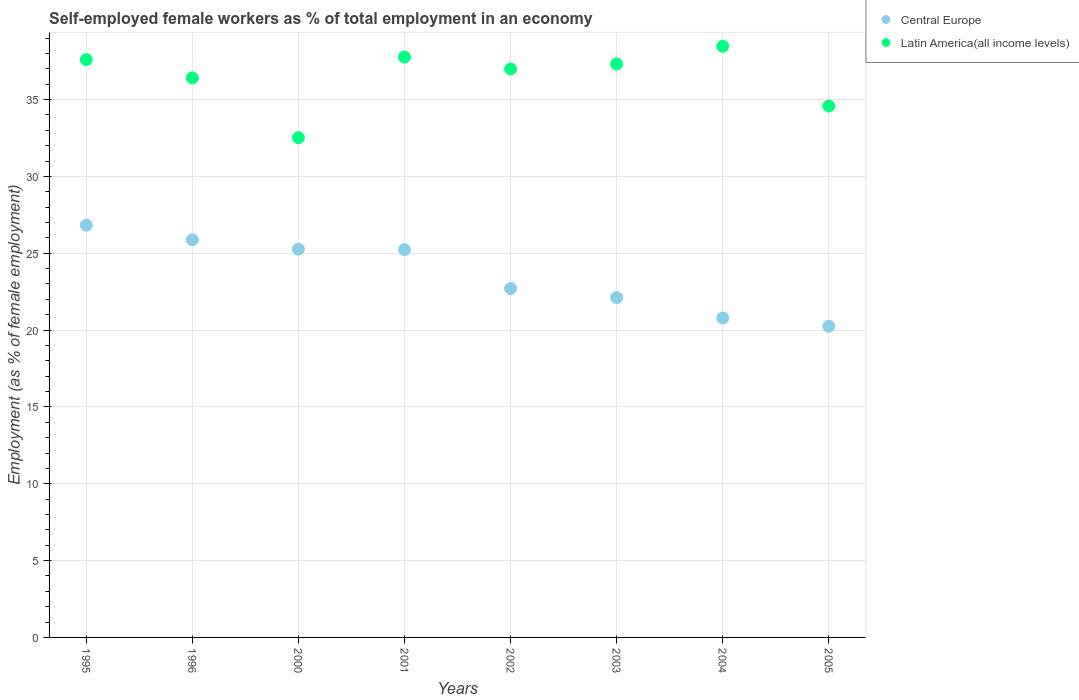Is the number of dotlines equal to the number of legend labels?
Your response must be concise. Yes. What is the percentage of self-employed female workers in Latin America(all income levels) in 2002?
Keep it short and to the point. 36.99. Across all years, what is the maximum percentage of self-employed female workers in Central Europe?
Your answer should be compact. 26.83. Across all years, what is the minimum percentage of self-employed female workers in Latin America(all income levels)?
Give a very brief answer. 32.52. What is the total percentage of self-employed female workers in Latin America(all income levels) in the graph?
Give a very brief answer. 291.67. What is the difference between the percentage of self-employed female workers in Central Europe in 2000 and that in 2004?
Your answer should be compact. 4.48. What is the difference between the percentage of self-employed female workers in Latin America(all income levels) in 1995 and the percentage of self-employed female workers in Central Europe in 2001?
Give a very brief answer. 12.37. What is the average percentage of self-employed female workers in Latin America(all income levels) per year?
Provide a short and direct response. 36.46. In the year 2005, what is the difference between the percentage of self-employed female workers in Latin America(all income levels) and percentage of self-employed female workers in Central Europe?
Your answer should be compact. 14.33. In how many years, is the percentage of self-employed female workers in Central Europe greater than 27 %?
Give a very brief answer. 0. What is the ratio of the percentage of self-employed female workers in Latin America(all income levels) in 1996 to that in 2001?
Make the answer very short. 0.96. Is the percentage of self-employed female workers in Central Europe in 2002 less than that in 2005?
Your answer should be very brief. No. Is the difference between the percentage of self-employed female workers in Latin America(all income levels) in 2001 and 2002 greater than the difference between the percentage of self-employed female workers in Central Europe in 2001 and 2002?
Provide a succinct answer. No. What is the difference between the highest and the second highest percentage of self-employed female workers in Central Europe?
Keep it short and to the point. 0.95. What is the difference between the highest and the lowest percentage of self-employed female workers in Latin America(all income levels)?
Offer a very short reply. 5.95. Does the percentage of self-employed female workers in Central Europe monotonically increase over the years?
Your response must be concise. No. Is the percentage of self-employed female workers in Latin America(all income levels) strictly greater than the percentage of self-employed female workers in Central Europe over the years?
Keep it short and to the point. Yes. How many dotlines are there?
Offer a very short reply. 2. What is the difference between two consecutive major ticks on the Y-axis?
Your response must be concise. 5. Are the values on the major ticks of Y-axis written in scientific E-notation?
Your answer should be very brief. No. Does the graph contain any zero values?
Provide a short and direct response. No. Where does the legend appear in the graph?
Provide a short and direct response. Top right. What is the title of the graph?
Keep it short and to the point. Self-employed female workers as % of total employment in an economy. Does "Guyana" appear as one of the legend labels in the graph?
Your response must be concise. No. What is the label or title of the X-axis?
Ensure brevity in your answer.  Years. What is the label or title of the Y-axis?
Ensure brevity in your answer.  Employment (as % of female employment). What is the Employment (as % of female employment) in Central Europe in 1995?
Give a very brief answer. 26.83. What is the Employment (as % of female employment) of Latin America(all income levels) in 1995?
Provide a short and direct response. 37.61. What is the Employment (as % of female employment) in Central Europe in 1996?
Give a very brief answer. 25.88. What is the Employment (as % of female employment) in Latin America(all income levels) in 1996?
Your answer should be compact. 36.41. What is the Employment (as % of female employment) in Central Europe in 2000?
Offer a terse response. 25.27. What is the Employment (as % of female employment) of Latin America(all income levels) in 2000?
Your answer should be compact. 32.52. What is the Employment (as % of female employment) in Central Europe in 2001?
Offer a terse response. 25.24. What is the Employment (as % of female employment) in Latin America(all income levels) in 2001?
Your response must be concise. 37.77. What is the Employment (as % of female employment) in Central Europe in 2002?
Provide a succinct answer. 22.71. What is the Employment (as % of female employment) of Latin America(all income levels) in 2002?
Give a very brief answer. 36.99. What is the Employment (as % of female employment) in Central Europe in 2003?
Keep it short and to the point. 22.12. What is the Employment (as % of female employment) of Latin America(all income levels) in 2003?
Offer a very short reply. 37.32. What is the Employment (as % of female employment) in Central Europe in 2004?
Your answer should be very brief. 20.78. What is the Employment (as % of female employment) of Latin America(all income levels) in 2004?
Keep it short and to the point. 38.47. What is the Employment (as % of female employment) in Central Europe in 2005?
Offer a very short reply. 20.25. What is the Employment (as % of female employment) in Latin America(all income levels) in 2005?
Your response must be concise. 34.58. Across all years, what is the maximum Employment (as % of female employment) of Central Europe?
Offer a terse response. 26.83. Across all years, what is the maximum Employment (as % of female employment) in Latin America(all income levels)?
Offer a very short reply. 38.47. Across all years, what is the minimum Employment (as % of female employment) of Central Europe?
Keep it short and to the point. 20.25. Across all years, what is the minimum Employment (as % of female employment) in Latin America(all income levels)?
Offer a terse response. 32.52. What is the total Employment (as % of female employment) in Central Europe in the graph?
Your response must be concise. 189.07. What is the total Employment (as % of female employment) in Latin America(all income levels) in the graph?
Provide a short and direct response. 291.67. What is the difference between the Employment (as % of female employment) of Central Europe in 1995 and that in 1996?
Ensure brevity in your answer.  0.95. What is the difference between the Employment (as % of female employment) of Latin America(all income levels) in 1995 and that in 1996?
Your answer should be compact. 1.2. What is the difference between the Employment (as % of female employment) in Central Europe in 1995 and that in 2000?
Offer a very short reply. 1.57. What is the difference between the Employment (as % of female employment) of Latin America(all income levels) in 1995 and that in 2000?
Give a very brief answer. 5.08. What is the difference between the Employment (as % of female employment) of Central Europe in 1995 and that in 2001?
Provide a short and direct response. 1.59. What is the difference between the Employment (as % of female employment) in Latin America(all income levels) in 1995 and that in 2001?
Provide a succinct answer. -0.17. What is the difference between the Employment (as % of female employment) in Central Europe in 1995 and that in 2002?
Offer a terse response. 4.12. What is the difference between the Employment (as % of female employment) in Latin America(all income levels) in 1995 and that in 2002?
Give a very brief answer. 0.61. What is the difference between the Employment (as % of female employment) in Central Europe in 1995 and that in 2003?
Give a very brief answer. 4.72. What is the difference between the Employment (as % of female employment) of Latin America(all income levels) in 1995 and that in 2003?
Your answer should be very brief. 0.29. What is the difference between the Employment (as % of female employment) in Central Europe in 1995 and that in 2004?
Your answer should be compact. 6.05. What is the difference between the Employment (as % of female employment) in Latin America(all income levels) in 1995 and that in 2004?
Your answer should be very brief. -0.86. What is the difference between the Employment (as % of female employment) of Central Europe in 1995 and that in 2005?
Ensure brevity in your answer.  6.59. What is the difference between the Employment (as % of female employment) of Latin America(all income levels) in 1995 and that in 2005?
Offer a very short reply. 3.03. What is the difference between the Employment (as % of female employment) in Central Europe in 1996 and that in 2000?
Your answer should be very brief. 0.61. What is the difference between the Employment (as % of female employment) of Latin America(all income levels) in 1996 and that in 2000?
Provide a short and direct response. 3.89. What is the difference between the Employment (as % of female employment) in Central Europe in 1996 and that in 2001?
Offer a very short reply. 0.64. What is the difference between the Employment (as % of female employment) in Latin America(all income levels) in 1996 and that in 2001?
Give a very brief answer. -1.36. What is the difference between the Employment (as % of female employment) in Central Europe in 1996 and that in 2002?
Give a very brief answer. 3.17. What is the difference between the Employment (as % of female employment) in Latin America(all income levels) in 1996 and that in 2002?
Provide a short and direct response. -0.58. What is the difference between the Employment (as % of female employment) of Central Europe in 1996 and that in 2003?
Ensure brevity in your answer.  3.76. What is the difference between the Employment (as % of female employment) of Latin America(all income levels) in 1996 and that in 2003?
Ensure brevity in your answer.  -0.91. What is the difference between the Employment (as % of female employment) in Central Europe in 1996 and that in 2004?
Your response must be concise. 5.1. What is the difference between the Employment (as % of female employment) in Latin America(all income levels) in 1996 and that in 2004?
Provide a succinct answer. -2.06. What is the difference between the Employment (as % of female employment) in Central Europe in 1996 and that in 2005?
Provide a succinct answer. 5.63. What is the difference between the Employment (as % of female employment) of Latin America(all income levels) in 1996 and that in 2005?
Ensure brevity in your answer.  1.83. What is the difference between the Employment (as % of female employment) in Central Europe in 2000 and that in 2001?
Keep it short and to the point. 0.03. What is the difference between the Employment (as % of female employment) of Latin America(all income levels) in 2000 and that in 2001?
Offer a very short reply. -5.25. What is the difference between the Employment (as % of female employment) in Central Europe in 2000 and that in 2002?
Provide a short and direct response. 2.56. What is the difference between the Employment (as % of female employment) of Latin America(all income levels) in 2000 and that in 2002?
Ensure brevity in your answer.  -4.47. What is the difference between the Employment (as % of female employment) in Central Europe in 2000 and that in 2003?
Your answer should be very brief. 3.15. What is the difference between the Employment (as % of female employment) in Latin America(all income levels) in 2000 and that in 2003?
Offer a terse response. -4.8. What is the difference between the Employment (as % of female employment) in Central Europe in 2000 and that in 2004?
Ensure brevity in your answer.  4.48. What is the difference between the Employment (as % of female employment) in Latin America(all income levels) in 2000 and that in 2004?
Give a very brief answer. -5.95. What is the difference between the Employment (as % of female employment) of Central Europe in 2000 and that in 2005?
Offer a very short reply. 5.02. What is the difference between the Employment (as % of female employment) in Latin America(all income levels) in 2000 and that in 2005?
Ensure brevity in your answer.  -2.06. What is the difference between the Employment (as % of female employment) in Central Europe in 2001 and that in 2002?
Ensure brevity in your answer.  2.53. What is the difference between the Employment (as % of female employment) in Latin America(all income levels) in 2001 and that in 2002?
Your answer should be very brief. 0.78. What is the difference between the Employment (as % of female employment) in Central Europe in 2001 and that in 2003?
Provide a short and direct response. 3.12. What is the difference between the Employment (as % of female employment) in Latin America(all income levels) in 2001 and that in 2003?
Provide a short and direct response. 0.45. What is the difference between the Employment (as % of female employment) in Central Europe in 2001 and that in 2004?
Your response must be concise. 4.46. What is the difference between the Employment (as % of female employment) in Latin America(all income levels) in 2001 and that in 2004?
Provide a succinct answer. -0.7. What is the difference between the Employment (as % of female employment) in Central Europe in 2001 and that in 2005?
Provide a short and direct response. 4.99. What is the difference between the Employment (as % of female employment) of Latin America(all income levels) in 2001 and that in 2005?
Give a very brief answer. 3.19. What is the difference between the Employment (as % of female employment) of Central Europe in 2002 and that in 2003?
Offer a very short reply. 0.59. What is the difference between the Employment (as % of female employment) of Latin America(all income levels) in 2002 and that in 2003?
Provide a short and direct response. -0.32. What is the difference between the Employment (as % of female employment) in Central Europe in 2002 and that in 2004?
Offer a terse response. 1.92. What is the difference between the Employment (as % of female employment) of Latin America(all income levels) in 2002 and that in 2004?
Offer a very short reply. -1.48. What is the difference between the Employment (as % of female employment) of Central Europe in 2002 and that in 2005?
Offer a terse response. 2.46. What is the difference between the Employment (as % of female employment) in Latin America(all income levels) in 2002 and that in 2005?
Your response must be concise. 2.42. What is the difference between the Employment (as % of female employment) in Central Europe in 2003 and that in 2004?
Ensure brevity in your answer.  1.33. What is the difference between the Employment (as % of female employment) of Latin America(all income levels) in 2003 and that in 2004?
Keep it short and to the point. -1.15. What is the difference between the Employment (as % of female employment) of Central Europe in 2003 and that in 2005?
Ensure brevity in your answer.  1.87. What is the difference between the Employment (as % of female employment) in Latin America(all income levels) in 2003 and that in 2005?
Provide a succinct answer. 2.74. What is the difference between the Employment (as % of female employment) in Central Europe in 2004 and that in 2005?
Your response must be concise. 0.54. What is the difference between the Employment (as % of female employment) of Latin America(all income levels) in 2004 and that in 2005?
Make the answer very short. 3.89. What is the difference between the Employment (as % of female employment) in Central Europe in 1995 and the Employment (as % of female employment) in Latin America(all income levels) in 1996?
Make the answer very short. -9.58. What is the difference between the Employment (as % of female employment) of Central Europe in 1995 and the Employment (as % of female employment) of Latin America(all income levels) in 2000?
Make the answer very short. -5.69. What is the difference between the Employment (as % of female employment) in Central Europe in 1995 and the Employment (as % of female employment) in Latin America(all income levels) in 2001?
Offer a terse response. -10.94. What is the difference between the Employment (as % of female employment) in Central Europe in 1995 and the Employment (as % of female employment) in Latin America(all income levels) in 2002?
Give a very brief answer. -10.16. What is the difference between the Employment (as % of female employment) of Central Europe in 1995 and the Employment (as % of female employment) of Latin America(all income levels) in 2003?
Ensure brevity in your answer.  -10.49. What is the difference between the Employment (as % of female employment) of Central Europe in 1995 and the Employment (as % of female employment) of Latin America(all income levels) in 2004?
Offer a very short reply. -11.64. What is the difference between the Employment (as % of female employment) of Central Europe in 1995 and the Employment (as % of female employment) of Latin America(all income levels) in 2005?
Provide a short and direct response. -7.75. What is the difference between the Employment (as % of female employment) in Central Europe in 1996 and the Employment (as % of female employment) in Latin America(all income levels) in 2000?
Keep it short and to the point. -6.64. What is the difference between the Employment (as % of female employment) in Central Europe in 1996 and the Employment (as % of female employment) in Latin America(all income levels) in 2001?
Your answer should be very brief. -11.89. What is the difference between the Employment (as % of female employment) of Central Europe in 1996 and the Employment (as % of female employment) of Latin America(all income levels) in 2002?
Provide a succinct answer. -11.11. What is the difference between the Employment (as % of female employment) in Central Europe in 1996 and the Employment (as % of female employment) in Latin America(all income levels) in 2003?
Give a very brief answer. -11.44. What is the difference between the Employment (as % of female employment) of Central Europe in 1996 and the Employment (as % of female employment) of Latin America(all income levels) in 2004?
Your answer should be compact. -12.59. What is the difference between the Employment (as % of female employment) in Central Europe in 1996 and the Employment (as % of female employment) in Latin America(all income levels) in 2005?
Give a very brief answer. -8.7. What is the difference between the Employment (as % of female employment) in Central Europe in 2000 and the Employment (as % of female employment) in Latin America(all income levels) in 2001?
Your answer should be very brief. -12.51. What is the difference between the Employment (as % of female employment) in Central Europe in 2000 and the Employment (as % of female employment) in Latin America(all income levels) in 2002?
Your answer should be very brief. -11.73. What is the difference between the Employment (as % of female employment) in Central Europe in 2000 and the Employment (as % of female employment) in Latin America(all income levels) in 2003?
Give a very brief answer. -12.05. What is the difference between the Employment (as % of female employment) in Central Europe in 2000 and the Employment (as % of female employment) in Latin America(all income levels) in 2004?
Provide a short and direct response. -13.2. What is the difference between the Employment (as % of female employment) of Central Europe in 2000 and the Employment (as % of female employment) of Latin America(all income levels) in 2005?
Offer a terse response. -9.31. What is the difference between the Employment (as % of female employment) of Central Europe in 2001 and the Employment (as % of female employment) of Latin America(all income levels) in 2002?
Offer a terse response. -11.75. What is the difference between the Employment (as % of female employment) in Central Europe in 2001 and the Employment (as % of female employment) in Latin America(all income levels) in 2003?
Make the answer very short. -12.08. What is the difference between the Employment (as % of female employment) of Central Europe in 2001 and the Employment (as % of female employment) of Latin America(all income levels) in 2004?
Keep it short and to the point. -13.23. What is the difference between the Employment (as % of female employment) in Central Europe in 2001 and the Employment (as % of female employment) in Latin America(all income levels) in 2005?
Make the answer very short. -9.34. What is the difference between the Employment (as % of female employment) of Central Europe in 2002 and the Employment (as % of female employment) of Latin America(all income levels) in 2003?
Offer a very short reply. -14.61. What is the difference between the Employment (as % of female employment) in Central Europe in 2002 and the Employment (as % of female employment) in Latin America(all income levels) in 2004?
Offer a very short reply. -15.76. What is the difference between the Employment (as % of female employment) of Central Europe in 2002 and the Employment (as % of female employment) of Latin America(all income levels) in 2005?
Ensure brevity in your answer.  -11.87. What is the difference between the Employment (as % of female employment) of Central Europe in 2003 and the Employment (as % of female employment) of Latin America(all income levels) in 2004?
Your answer should be very brief. -16.35. What is the difference between the Employment (as % of female employment) in Central Europe in 2003 and the Employment (as % of female employment) in Latin America(all income levels) in 2005?
Offer a terse response. -12.46. What is the difference between the Employment (as % of female employment) of Central Europe in 2004 and the Employment (as % of female employment) of Latin America(all income levels) in 2005?
Offer a terse response. -13.79. What is the average Employment (as % of female employment) of Central Europe per year?
Your response must be concise. 23.63. What is the average Employment (as % of female employment) of Latin America(all income levels) per year?
Provide a short and direct response. 36.46. In the year 1995, what is the difference between the Employment (as % of female employment) in Central Europe and Employment (as % of female employment) in Latin America(all income levels)?
Your answer should be very brief. -10.77. In the year 1996, what is the difference between the Employment (as % of female employment) of Central Europe and Employment (as % of female employment) of Latin America(all income levels)?
Ensure brevity in your answer.  -10.53. In the year 2000, what is the difference between the Employment (as % of female employment) of Central Europe and Employment (as % of female employment) of Latin America(all income levels)?
Provide a short and direct response. -7.26. In the year 2001, what is the difference between the Employment (as % of female employment) of Central Europe and Employment (as % of female employment) of Latin America(all income levels)?
Ensure brevity in your answer.  -12.53. In the year 2002, what is the difference between the Employment (as % of female employment) in Central Europe and Employment (as % of female employment) in Latin America(all income levels)?
Provide a succinct answer. -14.29. In the year 2003, what is the difference between the Employment (as % of female employment) of Central Europe and Employment (as % of female employment) of Latin America(all income levels)?
Offer a very short reply. -15.2. In the year 2004, what is the difference between the Employment (as % of female employment) in Central Europe and Employment (as % of female employment) in Latin America(all income levels)?
Ensure brevity in your answer.  -17.69. In the year 2005, what is the difference between the Employment (as % of female employment) of Central Europe and Employment (as % of female employment) of Latin America(all income levels)?
Provide a succinct answer. -14.33. What is the ratio of the Employment (as % of female employment) in Central Europe in 1995 to that in 1996?
Your response must be concise. 1.04. What is the ratio of the Employment (as % of female employment) in Latin America(all income levels) in 1995 to that in 1996?
Offer a terse response. 1.03. What is the ratio of the Employment (as % of female employment) in Central Europe in 1995 to that in 2000?
Offer a terse response. 1.06. What is the ratio of the Employment (as % of female employment) of Latin America(all income levels) in 1995 to that in 2000?
Give a very brief answer. 1.16. What is the ratio of the Employment (as % of female employment) in Central Europe in 1995 to that in 2001?
Your answer should be compact. 1.06. What is the ratio of the Employment (as % of female employment) of Latin America(all income levels) in 1995 to that in 2001?
Your answer should be compact. 1. What is the ratio of the Employment (as % of female employment) in Central Europe in 1995 to that in 2002?
Provide a short and direct response. 1.18. What is the ratio of the Employment (as % of female employment) in Latin America(all income levels) in 1995 to that in 2002?
Your response must be concise. 1.02. What is the ratio of the Employment (as % of female employment) of Central Europe in 1995 to that in 2003?
Offer a terse response. 1.21. What is the ratio of the Employment (as % of female employment) of Latin America(all income levels) in 1995 to that in 2003?
Provide a succinct answer. 1.01. What is the ratio of the Employment (as % of female employment) of Central Europe in 1995 to that in 2004?
Your answer should be compact. 1.29. What is the ratio of the Employment (as % of female employment) of Latin America(all income levels) in 1995 to that in 2004?
Offer a very short reply. 0.98. What is the ratio of the Employment (as % of female employment) in Central Europe in 1995 to that in 2005?
Your answer should be very brief. 1.33. What is the ratio of the Employment (as % of female employment) in Latin America(all income levels) in 1995 to that in 2005?
Provide a succinct answer. 1.09. What is the ratio of the Employment (as % of female employment) in Central Europe in 1996 to that in 2000?
Your response must be concise. 1.02. What is the ratio of the Employment (as % of female employment) of Latin America(all income levels) in 1996 to that in 2000?
Your answer should be compact. 1.12. What is the ratio of the Employment (as % of female employment) of Central Europe in 1996 to that in 2001?
Provide a short and direct response. 1.03. What is the ratio of the Employment (as % of female employment) in Latin America(all income levels) in 1996 to that in 2001?
Your response must be concise. 0.96. What is the ratio of the Employment (as % of female employment) of Central Europe in 1996 to that in 2002?
Ensure brevity in your answer.  1.14. What is the ratio of the Employment (as % of female employment) of Latin America(all income levels) in 1996 to that in 2002?
Give a very brief answer. 0.98. What is the ratio of the Employment (as % of female employment) of Central Europe in 1996 to that in 2003?
Your answer should be very brief. 1.17. What is the ratio of the Employment (as % of female employment) in Latin America(all income levels) in 1996 to that in 2003?
Offer a terse response. 0.98. What is the ratio of the Employment (as % of female employment) in Central Europe in 1996 to that in 2004?
Provide a short and direct response. 1.25. What is the ratio of the Employment (as % of female employment) in Latin America(all income levels) in 1996 to that in 2004?
Offer a very short reply. 0.95. What is the ratio of the Employment (as % of female employment) of Central Europe in 1996 to that in 2005?
Make the answer very short. 1.28. What is the ratio of the Employment (as % of female employment) of Latin America(all income levels) in 1996 to that in 2005?
Provide a succinct answer. 1.05. What is the ratio of the Employment (as % of female employment) in Central Europe in 2000 to that in 2001?
Your answer should be very brief. 1. What is the ratio of the Employment (as % of female employment) of Latin America(all income levels) in 2000 to that in 2001?
Offer a very short reply. 0.86. What is the ratio of the Employment (as % of female employment) in Central Europe in 2000 to that in 2002?
Offer a very short reply. 1.11. What is the ratio of the Employment (as % of female employment) in Latin America(all income levels) in 2000 to that in 2002?
Your answer should be compact. 0.88. What is the ratio of the Employment (as % of female employment) of Central Europe in 2000 to that in 2003?
Your answer should be compact. 1.14. What is the ratio of the Employment (as % of female employment) in Latin America(all income levels) in 2000 to that in 2003?
Your response must be concise. 0.87. What is the ratio of the Employment (as % of female employment) in Central Europe in 2000 to that in 2004?
Keep it short and to the point. 1.22. What is the ratio of the Employment (as % of female employment) of Latin America(all income levels) in 2000 to that in 2004?
Provide a succinct answer. 0.85. What is the ratio of the Employment (as % of female employment) in Central Europe in 2000 to that in 2005?
Your answer should be compact. 1.25. What is the ratio of the Employment (as % of female employment) in Latin America(all income levels) in 2000 to that in 2005?
Your answer should be compact. 0.94. What is the ratio of the Employment (as % of female employment) in Central Europe in 2001 to that in 2002?
Your response must be concise. 1.11. What is the ratio of the Employment (as % of female employment) in Central Europe in 2001 to that in 2003?
Give a very brief answer. 1.14. What is the ratio of the Employment (as % of female employment) in Latin America(all income levels) in 2001 to that in 2003?
Give a very brief answer. 1.01. What is the ratio of the Employment (as % of female employment) in Central Europe in 2001 to that in 2004?
Keep it short and to the point. 1.21. What is the ratio of the Employment (as % of female employment) of Latin America(all income levels) in 2001 to that in 2004?
Provide a short and direct response. 0.98. What is the ratio of the Employment (as % of female employment) in Central Europe in 2001 to that in 2005?
Provide a short and direct response. 1.25. What is the ratio of the Employment (as % of female employment) of Latin America(all income levels) in 2001 to that in 2005?
Provide a succinct answer. 1.09. What is the ratio of the Employment (as % of female employment) in Central Europe in 2002 to that in 2003?
Ensure brevity in your answer.  1.03. What is the ratio of the Employment (as % of female employment) of Central Europe in 2002 to that in 2004?
Ensure brevity in your answer.  1.09. What is the ratio of the Employment (as % of female employment) in Latin America(all income levels) in 2002 to that in 2004?
Offer a very short reply. 0.96. What is the ratio of the Employment (as % of female employment) in Central Europe in 2002 to that in 2005?
Give a very brief answer. 1.12. What is the ratio of the Employment (as % of female employment) of Latin America(all income levels) in 2002 to that in 2005?
Offer a very short reply. 1.07. What is the ratio of the Employment (as % of female employment) of Central Europe in 2003 to that in 2004?
Your answer should be very brief. 1.06. What is the ratio of the Employment (as % of female employment) in Latin America(all income levels) in 2003 to that in 2004?
Make the answer very short. 0.97. What is the ratio of the Employment (as % of female employment) in Central Europe in 2003 to that in 2005?
Make the answer very short. 1.09. What is the ratio of the Employment (as % of female employment) of Latin America(all income levels) in 2003 to that in 2005?
Give a very brief answer. 1.08. What is the ratio of the Employment (as % of female employment) in Central Europe in 2004 to that in 2005?
Give a very brief answer. 1.03. What is the ratio of the Employment (as % of female employment) in Latin America(all income levels) in 2004 to that in 2005?
Your response must be concise. 1.11. What is the difference between the highest and the second highest Employment (as % of female employment) of Central Europe?
Provide a short and direct response. 0.95. What is the difference between the highest and the second highest Employment (as % of female employment) in Latin America(all income levels)?
Ensure brevity in your answer.  0.7. What is the difference between the highest and the lowest Employment (as % of female employment) of Central Europe?
Provide a succinct answer. 6.59. What is the difference between the highest and the lowest Employment (as % of female employment) in Latin America(all income levels)?
Keep it short and to the point. 5.95. 